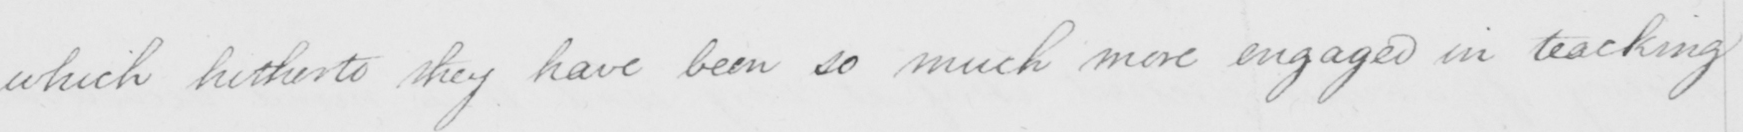Can you tell me what this handwritten text says? which hitherto they have been so much more engaged in teaching 